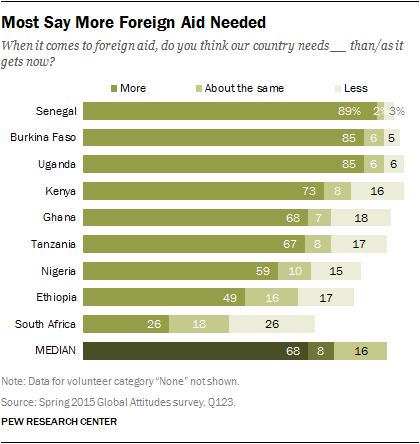Highlight a few significant elements in this photo. The maximum value of "more" is greater than the minimum value of "less". The value that is represented by the word "while" is a preposition. 